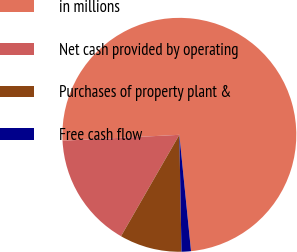<chart> <loc_0><loc_0><loc_500><loc_500><pie_chart><fcel>in millions<fcel>Net cash provided by operating<fcel>Purchases of property plant &<fcel>Free cash flow<nl><fcel>74.21%<fcel>15.89%<fcel>8.6%<fcel>1.3%<nl></chart> 